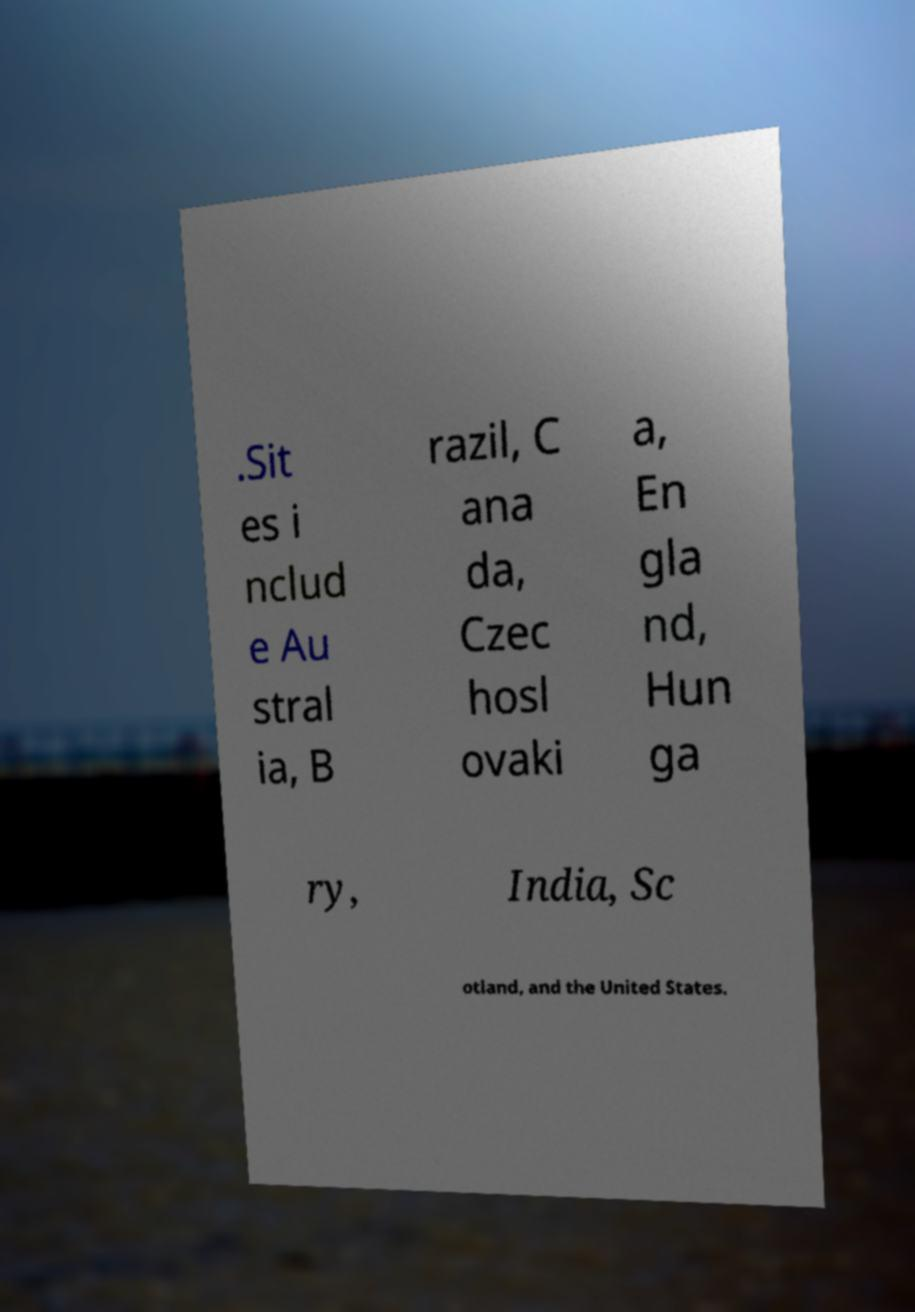What messages or text are displayed in this image? I need them in a readable, typed format. .Sit es i nclud e Au stral ia, B razil, C ana da, Czec hosl ovaki a, En gla nd, Hun ga ry, India, Sc otland, and the United States. 